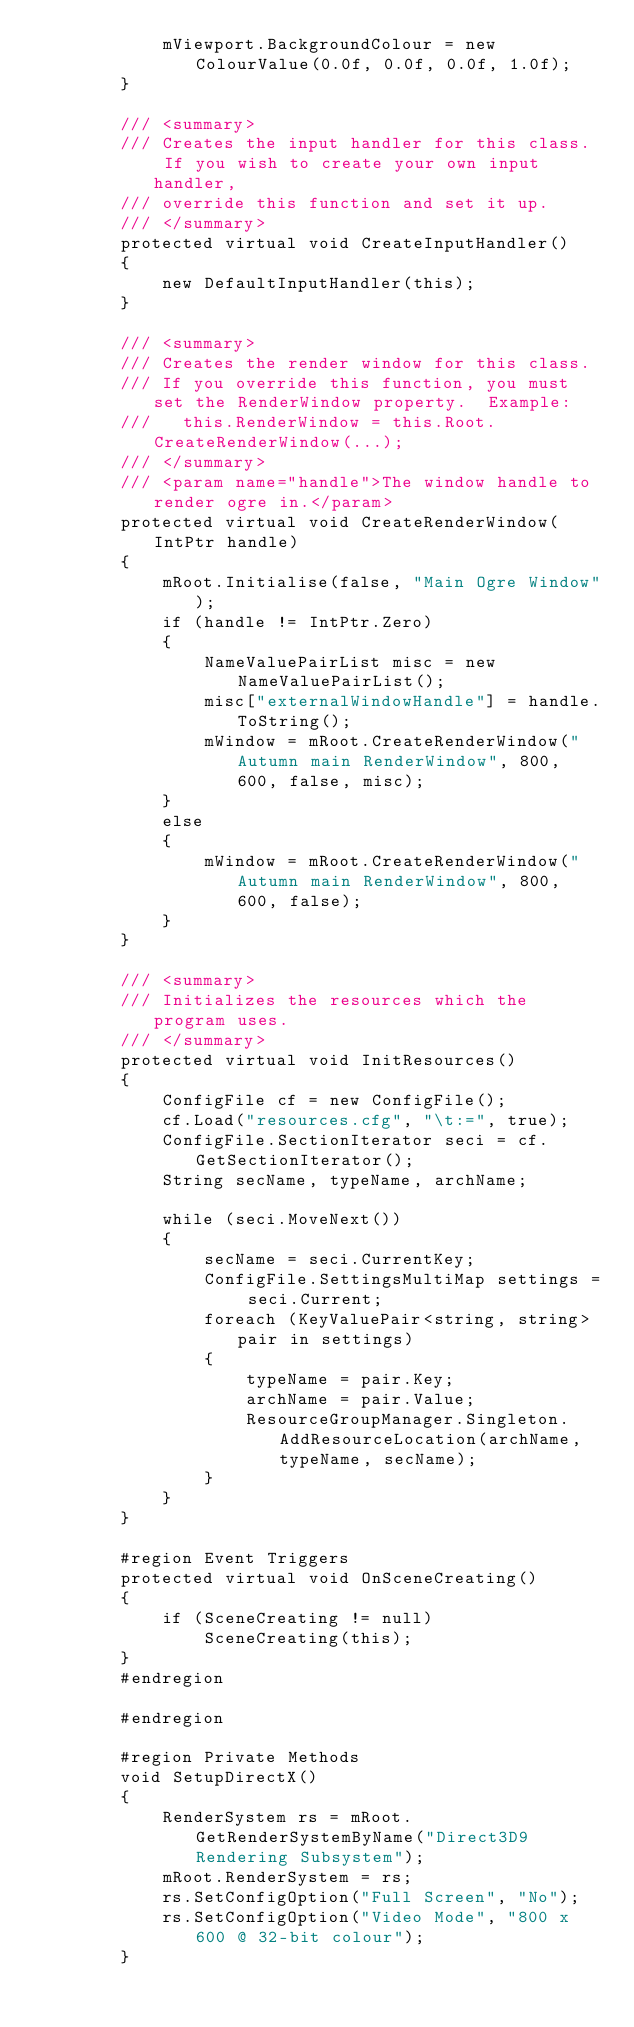Convert code to text. <code><loc_0><loc_0><loc_500><loc_500><_C#_>            mViewport.BackgroundColour = new ColourValue(0.0f, 0.0f, 0.0f, 1.0f);
        }

        /// <summary>
        /// Creates the input handler for this class.  If you wish to create your own input handler,
        /// override this function and set it up.
        /// </summary>
        protected virtual void CreateInputHandler()
        {
            new DefaultInputHandler(this);
        }

        /// <summary>
        /// Creates the render window for this class.
        /// If you override this function, you must set the RenderWindow property.  Example:
        ///   this.RenderWindow = this.Root.CreateRenderWindow(...);
        /// </summary>
        /// <param name="handle">The window handle to render ogre in.</param>
        protected virtual void CreateRenderWindow(IntPtr handle)
        {
            mRoot.Initialise(false, "Main Ogre Window");
            if (handle != IntPtr.Zero)
            {
                NameValuePairList misc = new NameValuePairList();
                misc["externalWindowHandle"] = handle.ToString();
                mWindow = mRoot.CreateRenderWindow("Autumn main RenderWindow", 800, 600, false, misc);
            }
            else
            {
                mWindow = mRoot.CreateRenderWindow("Autumn main RenderWindow", 800, 600, false);
            }
        }

        /// <summary>
        /// Initializes the resources which the program uses.
        /// </summary>
        protected virtual void InitResources()
        {
            ConfigFile cf = new ConfigFile();
            cf.Load("resources.cfg", "\t:=", true);
            ConfigFile.SectionIterator seci = cf.GetSectionIterator();
            String secName, typeName, archName;

            while (seci.MoveNext())
            {
                secName = seci.CurrentKey;
                ConfigFile.SettingsMultiMap settings = seci.Current;
                foreach (KeyValuePair<string, string> pair in settings)
                {
                    typeName = pair.Key;
                    archName = pair.Value;
                    ResourceGroupManager.Singleton.AddResourceLocation(archName, typeName, secName);
                }
            }
        }

        #region Event Triggers
        protected virtual void OnSceneCreating()
        {
            if (SceneCreating != null)
                SceneCreating(this);
        }
        #endregion

        #endregion

        #region Private Methods
        void SetupDirectX()
        {
            RenderSystem rs = mRoot.GetRenderSystemByName("Direct3D9 Rendering Subsystem");
            mRoot.RenderSystem = rs;
            rs.SetConfigOption("Full Screen", "No");
            rs.SetConfigOption("Video Mode", "800 x 600 @ 32-bit colour");
        }
</code> 